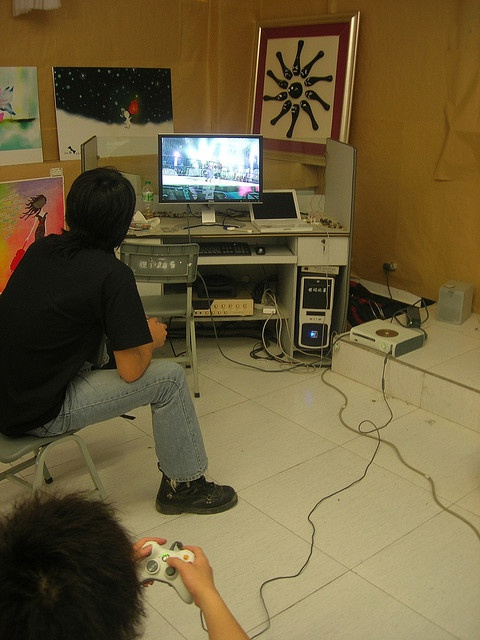Describe the objects in this image and their specific colors. I can see people in maroon, black, gray, darkgreen, and brown tones, people in maroon, black, tan, and olive tones, tv in maroon, white, black, lightblue, and gray tones, chair in maroon, darkgreen, black, and olive tones, and chair in maroon, darkgreen, olive, and black tones in this image. 